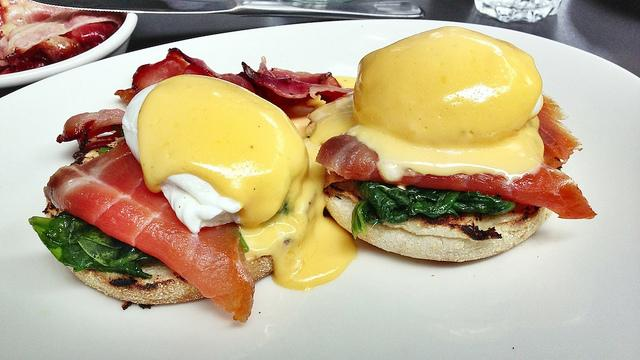What type of egg dish is shown? eggs benedict 